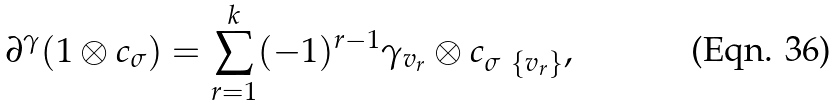Convert formula to latex. <formula><loc_0><loc_0><loc_500><loc_500>\partial ^ { \gamma } ( 1 \otimes c _ { \sigma } ) = \sum _ { r = 1 } ^ { k } ( - 1 ) ^ { r - 1 } \gamma _ { v _ { r } } \otimes c _ { \sigma \ \{ v _ { r } \} } ,</formula> 